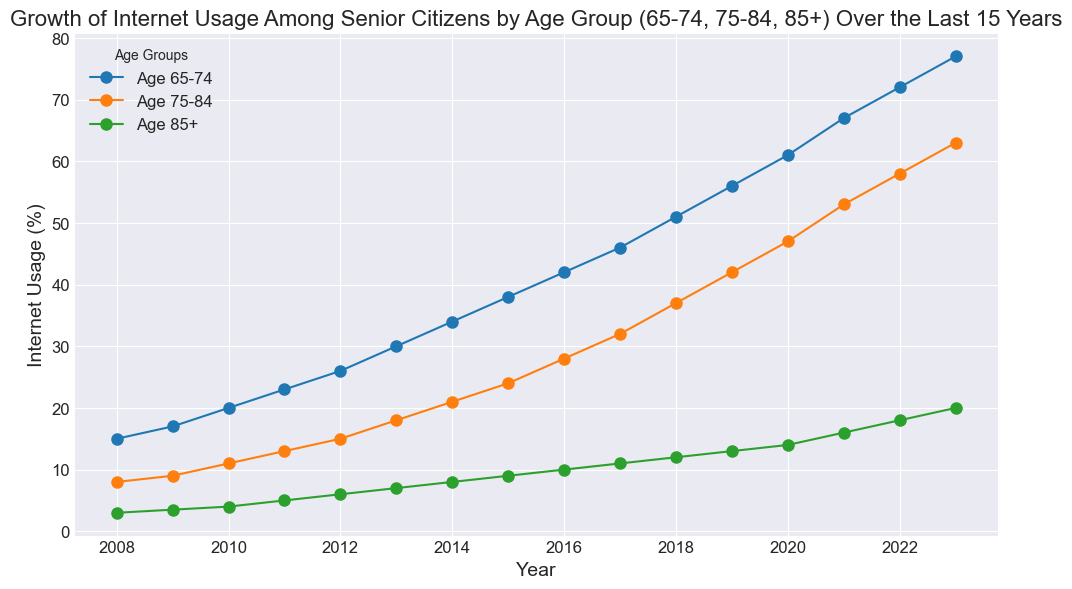What's the percentage increase in internet usage for the 65-74 age group from 2008 to 2023? The internet usage in 2008 for the 65-74 age group was 15%, and in 2023 it was 77%. The percentage increase can be calculated by taking the difference (77% - 15%) and dividing it by the initial value (15%), then multiplying by 100. So, ((77-15) / 15) * 100 = 413.33%.
Answer: 413.33% In which year did the 75-84 age group exceed 50% internet usage? Looking at the trend for the 75-84 age group, the percentage exceeds 50% in 2021 where the usage is 53%.
Answer: 2021 Which age group had the smallest increase in internet usage from 2008 to 2023? Calculate the increase for each group: 
  - 65-74 from 15% to 77%, an increase of 62%.
  - 75-84 from 8% to 63%, an increase of 55%.
  - 85+ from 3% to 20%, an increase of 17%.
The 85+ age group had the smallest increase.
Answer: 85+ By how much did the internet usage for the age group 85+ increase between 2010 and 2020? The internet usage for the 85+ age group was 4% in 2010 and 14% in 2020. The increase can be calculated by subtracting the values: 14% - 4% = 10%.
Answer: 10% Which year had the largest increase in internet usage for the 65-74 age group, and by how much did it increase? The year with the largest increase in internet usage can be identified by comparing consecutive years. The largest increase occurred between 2020 and 2021, rising from 61% to 67%, an increase of 6%.
Answer: 2021, 6% Which age group experienced the highest growth rate in internet usage over the 15 years? To find the highest growth rate, consider the percentage change relative to the initial year for each group:
  - 65-74: (77-15)/15 = 4.13 (413.33%)
  - 75-84: (63-8)/8 = 6.875 (687.5%)
  - 85+: (20-3)/3 = 5.67 (566.67%)
The 75-84 age group experienced the highest growth rate.
Answer: 75-84 How did internet usage compare for each age group in the year 2015? In 2015, the internet usage percentages for each age group were:
  - 65-74: 38%
  - 75-84: 24%
  - 85+: 9%
The 65-74 group had the highest, followed by 75-84 and then 85+.
Answer: 38%, 24%, 9% Which age group's internet usage first reached 30% and in which year? The 65-74 age group first reached 30% in 2013, as visible from the trend line.
Answer: 65-74, 2013 What is the average increase in internet usage per year for the 75-84 age group from 2008 to 2023? To find the average annual increase, subtract the 2008 value from the 2023 value and then divide by the number of years. For the 75-84 age group, (63-8)/15 = 3.67%.
Answer: 3.67% By how much did the internet usage of the 85+ age group increase between 2008 and 2023, and what percentage of that increase occurred between 2015 and 2020? The total increase from 2008 to 2023 for the 85+ age group was 20% - 3% = 17%. The increase from 2015 to 2020 was 14% - 9% = 5%, which is (5/17) * 100 = approximately 29.41% of the total increase.
Answer: 17%, 29.41% 